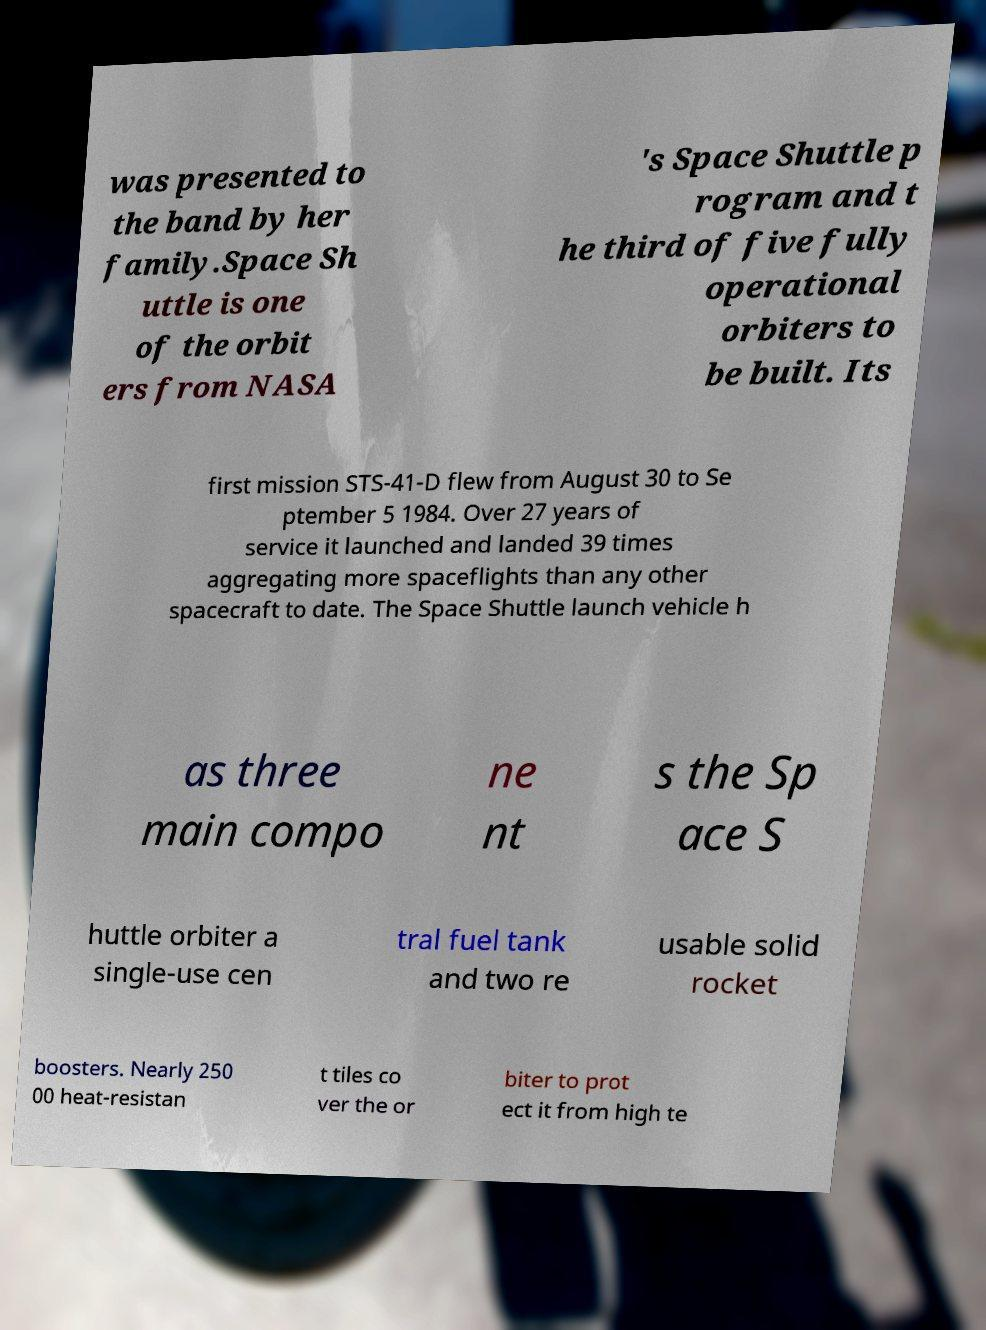I need the written content from this picture converted into text. Can you do that? was presented to the band by her family.Space Sh uttle is one of the orbit ers from NASA 's Space Shuttle p rogram and t he third of five fully operational orbiters to be built. Its first mission STS-41-D flew from August 30 to Se ptember 5 1984. Over 27 years of service it launched and landed 39 times aggregating more spaceflights than any other spacecraft to date. The Space Shuttle launch vehicle h as three main compo ne nt s the Sp ace S huttle orbiter a single-use cen tral fuel tank and two re usable solid rocket boosters. Nearly 250 00 heat-resistan t tiles co ver the or biter to prot ect it from high te 